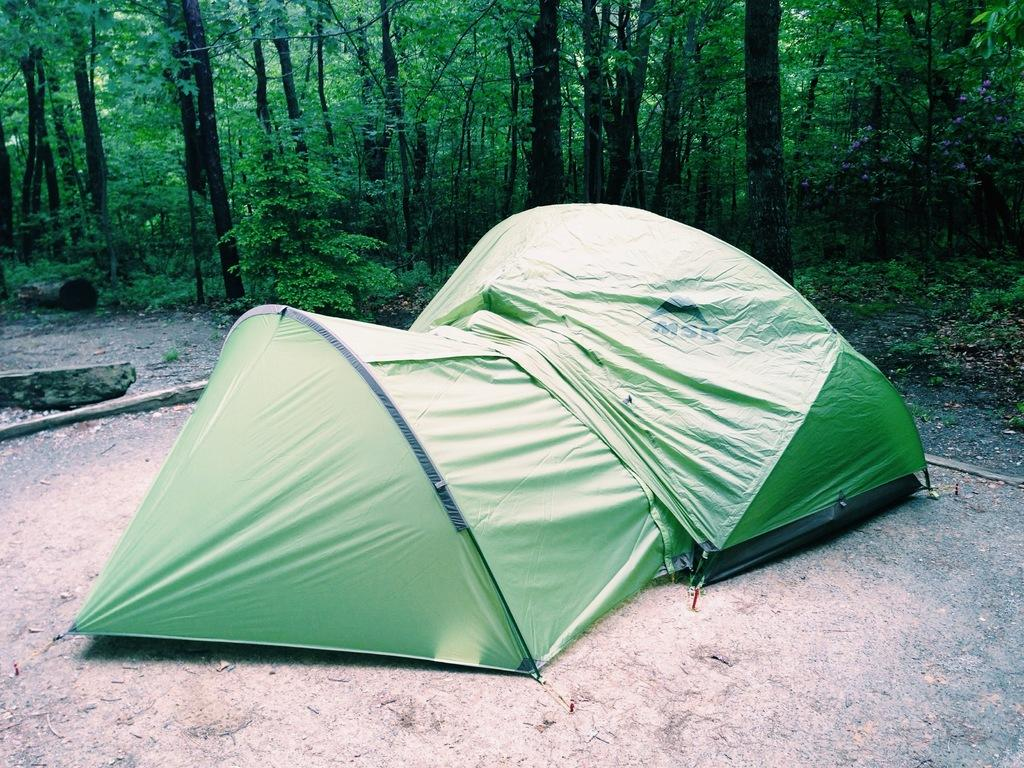What type of shelter is visible in the image? There is a green tent in the image. What can be seen in the background of the image? There are plants and trees in the background of the image. What type of substance is being used to make the straw in the image? There is no straw present in the image, so it is not possible to determine what substance might be used to make it. 